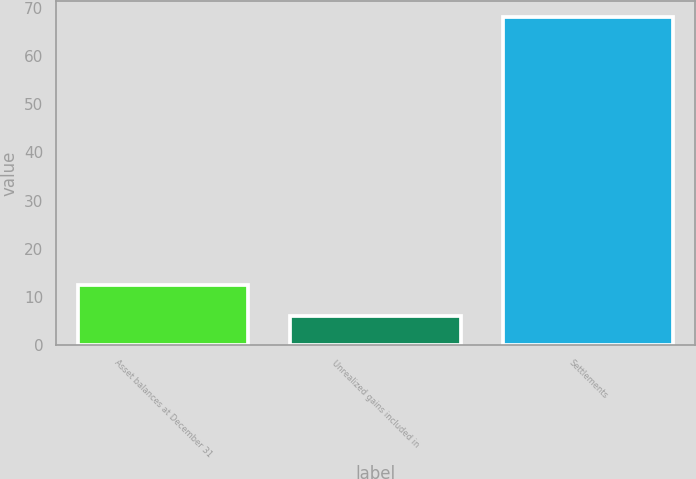Convert chart. <chart><loc_0><loc_0><loc_500><loc_500><bar_chart><fcel>Asset balances at December 31<fcel>Unrealized gains included in<fcel>Settlements<nl><fcel>12.4<fcel>6<fcel>68<nl></chart> 